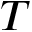Convert formula to latex. <formula><loc_0><loc_0><loc_500><loc_500>T</formula> 